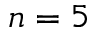Convert formula to latex. <formula><loc_0><loc_0><loc_500><loc_500>n = 5</formula> 